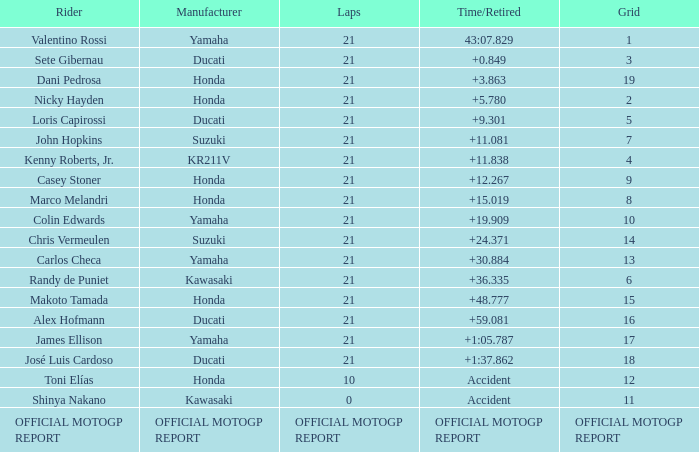Which rider had a time/retired od +19.909? Colin Edwards. 